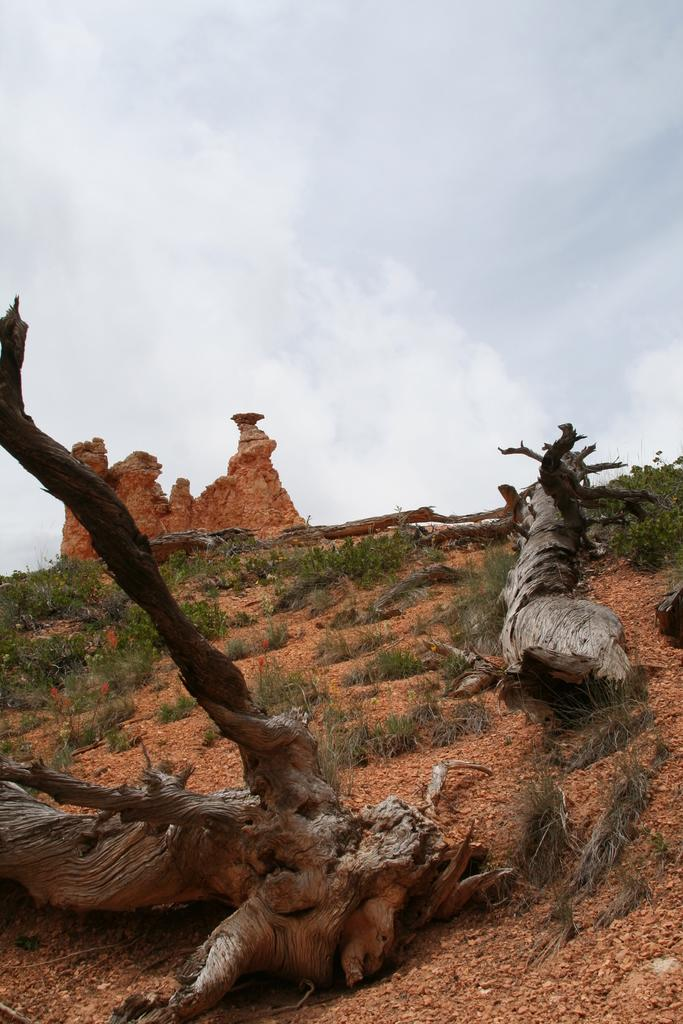What type of natural material is present in the image? There are wooden branches in the image. What type of living organisms can be seen in the image? There are plants in the image. What is the condition of the sky in the image? The sky is cloudy in the image. How many boats are visible in the image? There are no boats present in the image. What type of riddle can be solved using the wooden branches in the image? There is no riddle associated with the wooden branches in the image. 